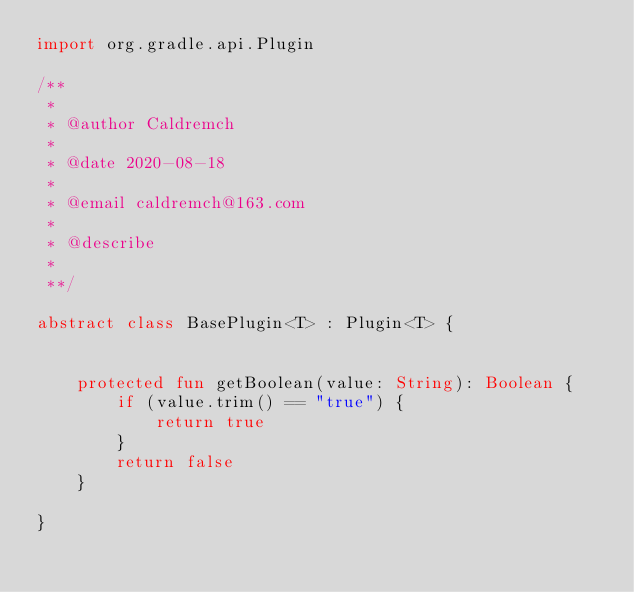<code> <loc_0><loc_0><loc_500><loc_500><_Kotlin_>import org.gradle.api.Plugin

/**
 *
 * @author Caldremch
 *
 * @date 2020-08-18
 *
 * @email caldremch@163.com
 *
 * @describe
 *
 **/

abstract class BasePlugin<T> : Plugin<T> {


    protected fun getBoolean(value: String): Boolean {
        if (value.trim() == "true") {
            return true
        }
        return false
    }

}</code> 